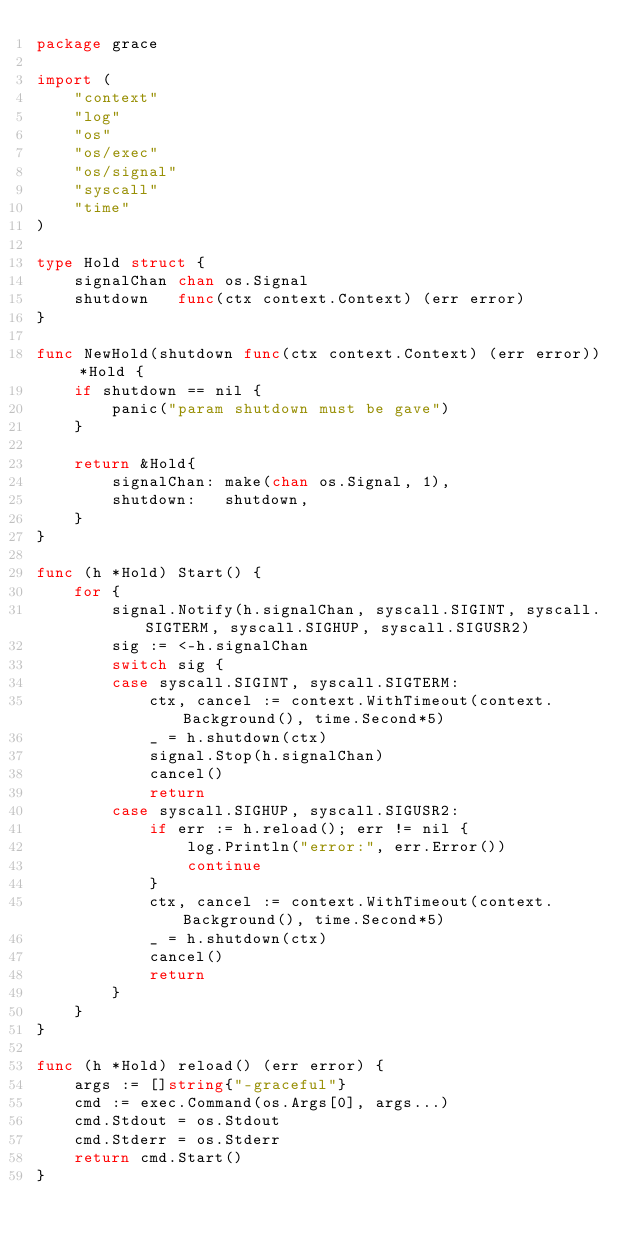<code> <loc_0><loc_0><loc_500><loc_500><_Go_>package grace

import (
	"context"
	"log"
	"os"
	"os/exec"
	"os/signal"
	"syscall"
	"time"
)

type Hold struct {
	signalChan chan os.Signal
	shutdown   func(ctx context.Context) (err error)
}

func NewHold(shutdown func(ctx context.Context) (err error)) *Hold {
	if shutdown == nil {
		panic("param shutdown must be gave")
	}

	return &Hold{
		signalChan: make(chan os.Signal, 1),
		shutdown:   shutdown,
	}
}

func (h *Hold) Start() {
	for {
		signal.Notify(h.signalChan, syscall.SIGINT, syscall.SIGTERM, syscall.SIGHUP, syscall.SIGUSR2)
		sig := <-h.signalChan
		switch sig {
		case syscall.SIGINT, syscall.SIGTERM:
			ctx, cancel := context.WithTimeout(context.Background(), time.Second*5)
			_ = h.shutdown(ctx)
			signal.Stop(h.signalChan)
			cancel()
			return
		case syscall.SIGHUP, syscall.SIGUSR2:
			if err := h.reload(); err != nil {
				log.Println("error:", err.Error())
				continue
			}
			ctx, cancel := context.WithTimeout(context.Background(), time.Second*5)
			_ = h.shutdown(ctx)
			cancel()
			return
		}
	}
}

func (h *Hold) reload() (err error) {
	args := []string{"-graceful"}
	cmd := exec.Command(os.Args[0], args...)
	cmd.Stdout = os.Stdout
	cmd.Stderr = os.Stderr
	return cmd.Start()
}
</code> 